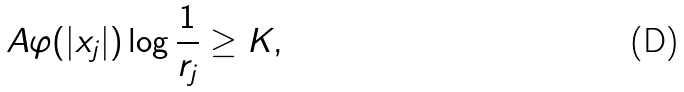Convert formula to latex. <formula><loc_0><loc_0><loc_500><loc_500>A \varphi ( | x _ { j } | ) \log \frac { 1 } { r _ { j } } \geq K ,</formula> 